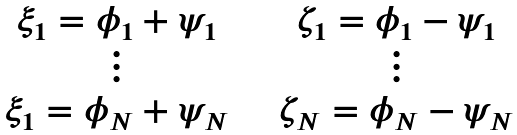Convert formula to latex. <formula><loc_0><loc_0><loc_500><loc_500>\begin{array} { c c c c } \xi _ { 1 } = \phi _ { 1 } + \psi _ { 1 } & & & \zeta _ { 1 } = \phi _ { 1 } - \psi _ { 1 } \\ \vdots & & & \vdots \\ \xi _ { 1 } = \phi _ { N } + \psi _ { N } & & & \zeta _ { N } = \phi _ { N } - \psi _ { N } \end{array}</formula> 